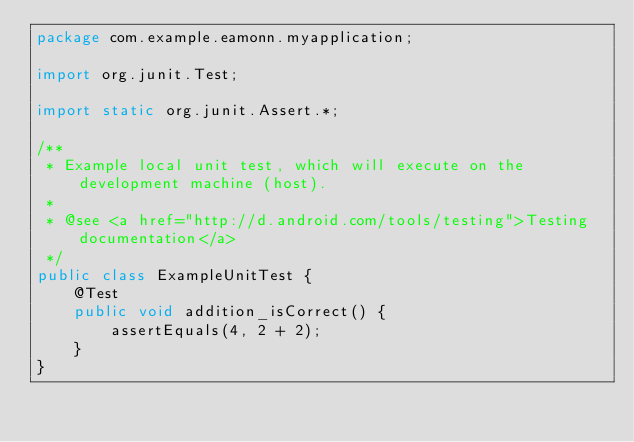<code> <loc_0><loc_0><loc_500><loc_500><_Java_>package com.example.eamonn.myapplication;

import org.junit.Test;

import static org.junit.Assert.*;

/**
 * Example local unit test, which will execute on the development machine (host).
 *
 * @see <a href="http://d.android.com/tools/testing">Testing documentation</a>
 */
public class ExampleUnitTest {
    @Test
    public void addition_isCorrect() {
        assertEquals(4, 2 + 2);
    }
}</code> 